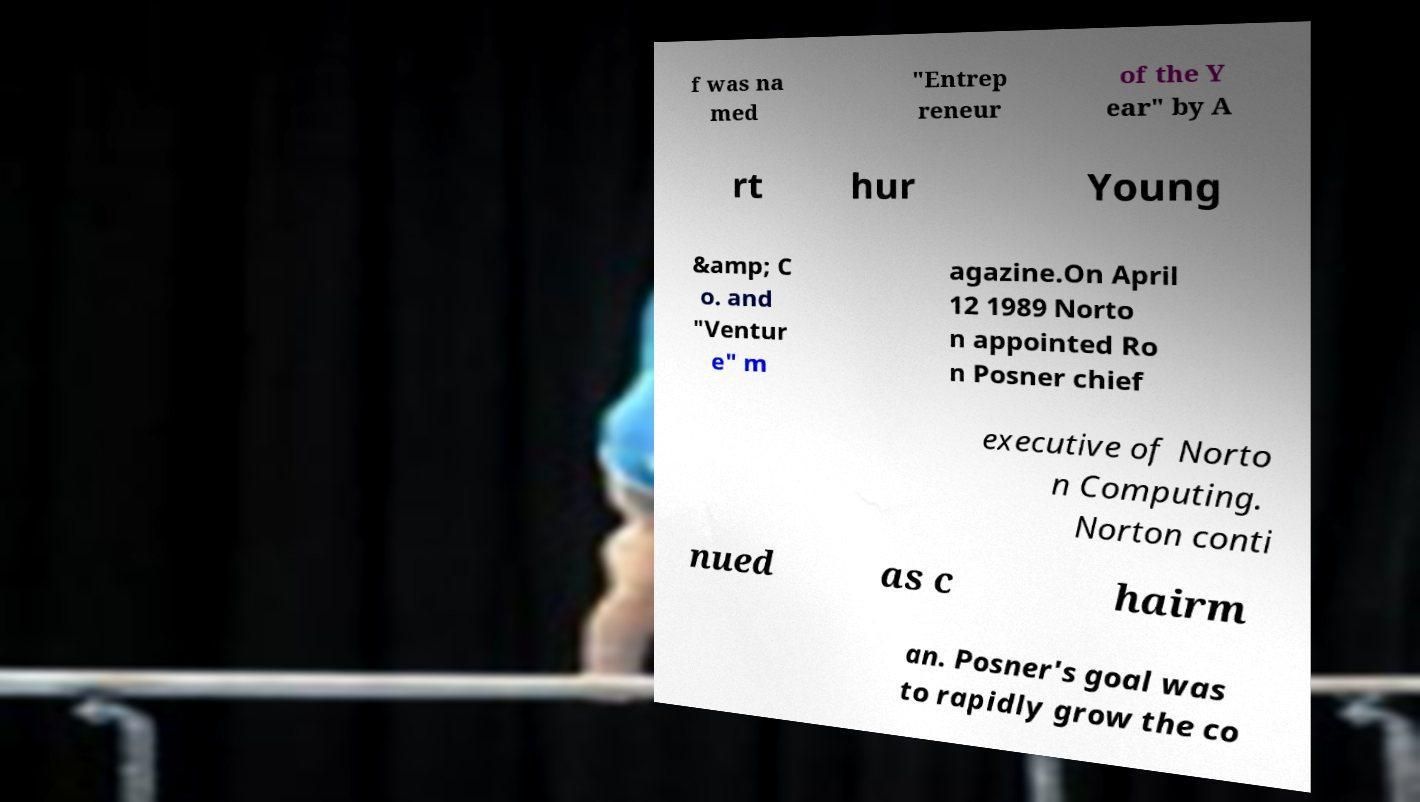I need the written content from this picture converted into text. Can you do that? f was na med "Entrep reneur of the Y ear" by A rt hur Young &amp; C o. and "Ventur e" m agazine.On April 12 1989 Norto n appointed Ro n Posner chief executive of Norto n Computing. Norton conti nued as c hairm an. Posner's goal was to rapidly grow the co 